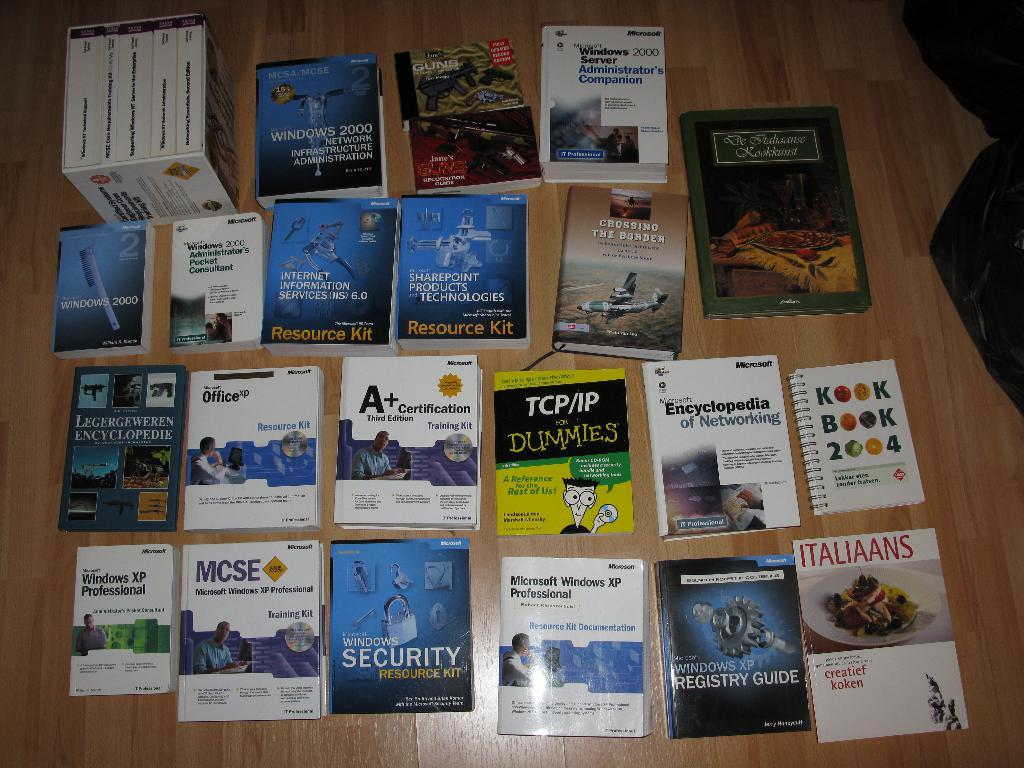<image>
Write a terse but informative summary of the picture. Books lined up that consist of Italians book, Microsoft Windows Security, and MCSE training kit book. 